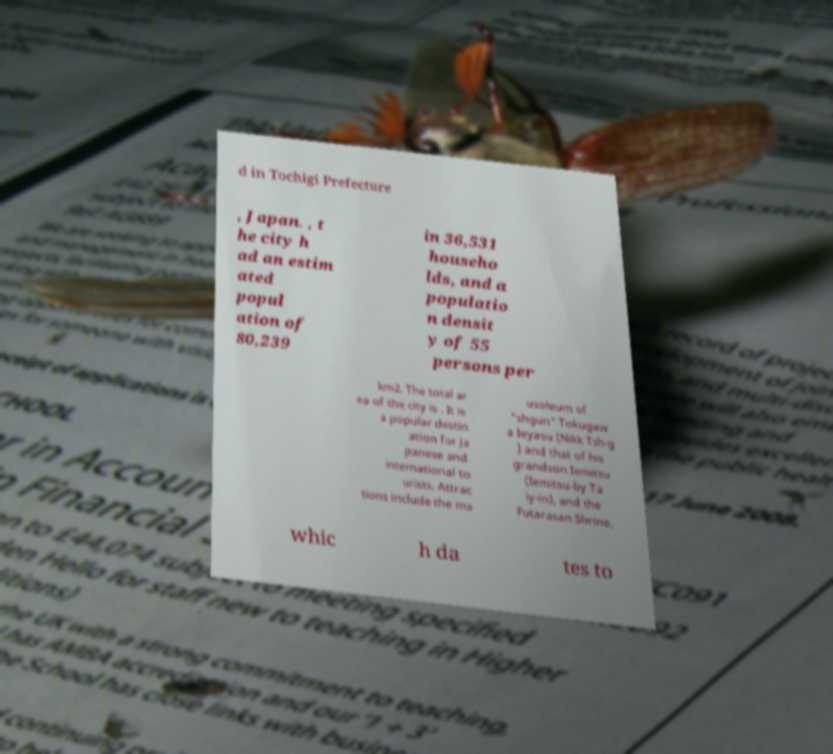Can you read and provide the text displayed in the image?This photo seems to have some interesting text. Can you extract and type it out for me? d in Tochigi Prefecture , Japan. , t he city h ad an estim ated popul ation of 80,239 in 36,531 househo lds, and a populatio n densit y of 55 persons per km2. The total ar ea of the city is . It is a popular destin ation for Ja panese and international to urists. Attrac tions include the ma usoleum of "shgun" Tokugaw a Ieyasu (Nikk Tsh-g ) and that of his grandson Iemitsu (Iemitsu-by Ta iy-in), and the Futarasan Shrine, whic h da tes to 